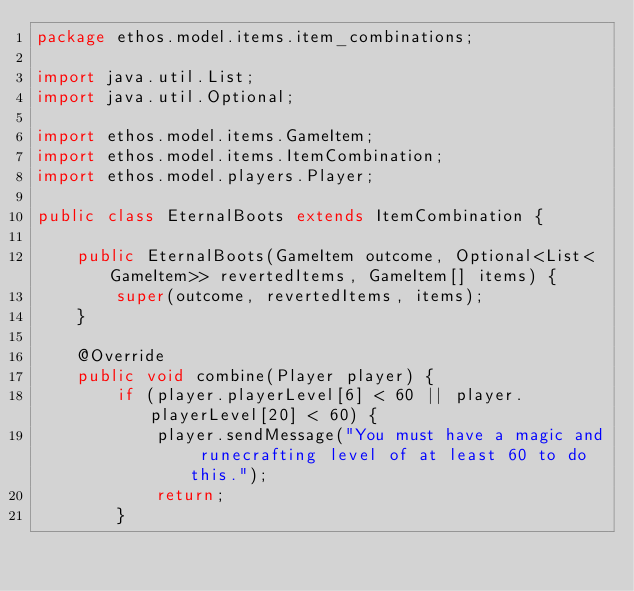<code> <loc_0><loc_0><loc_500><loc_500><_Java_>package ethos.model.items.item_combinations;

import java.util.List;
import java.util.Optional;

import ethos.model.items.GameItem;
import ethos.model.items.ItemCombination;
import ethos.model.players.Player;

public class EternalBoots extends ItemCombination {

	public EternalBoots(GameItem outcome, Optional<List<GameItem>> revertedItems, GameItem[] items) {
		super(outcome, revertedItems, items);
	}

	@Override
	public void combine(Player player) {
		if (player.playerLevel[6] < 60 || player.playerLevel[20] < 60) {
			player.sendMessage("You must have a magic and runecrafting level of at least 60 to do this.");
			return;
		}</code> 